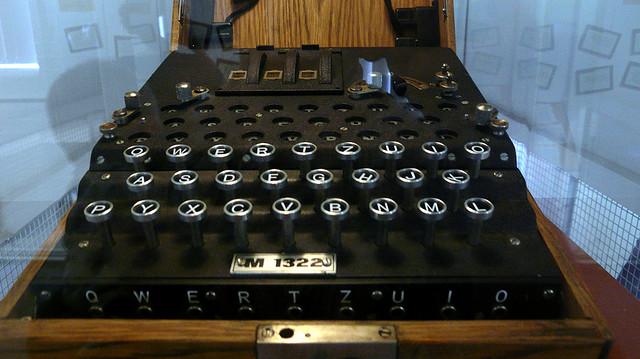Is the typewriter in a case?
Give a very brief answer. Yes. How many keys are on this old typewriter?
Answer briefly. 26. Is there paper in the typewriter?
Keep it brief. No. 